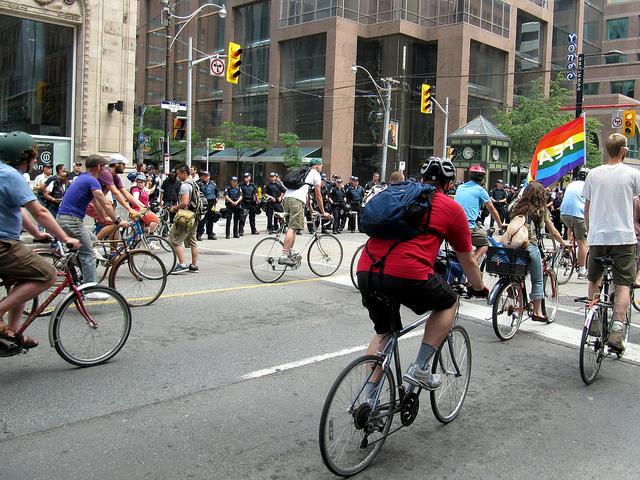Are all the bike riders going the same way?
Concise answer only. Yes. What color is the rider in red's backpack?
Write a very short answer. Blue. Is this a country setting?
Keep it brief. No. 